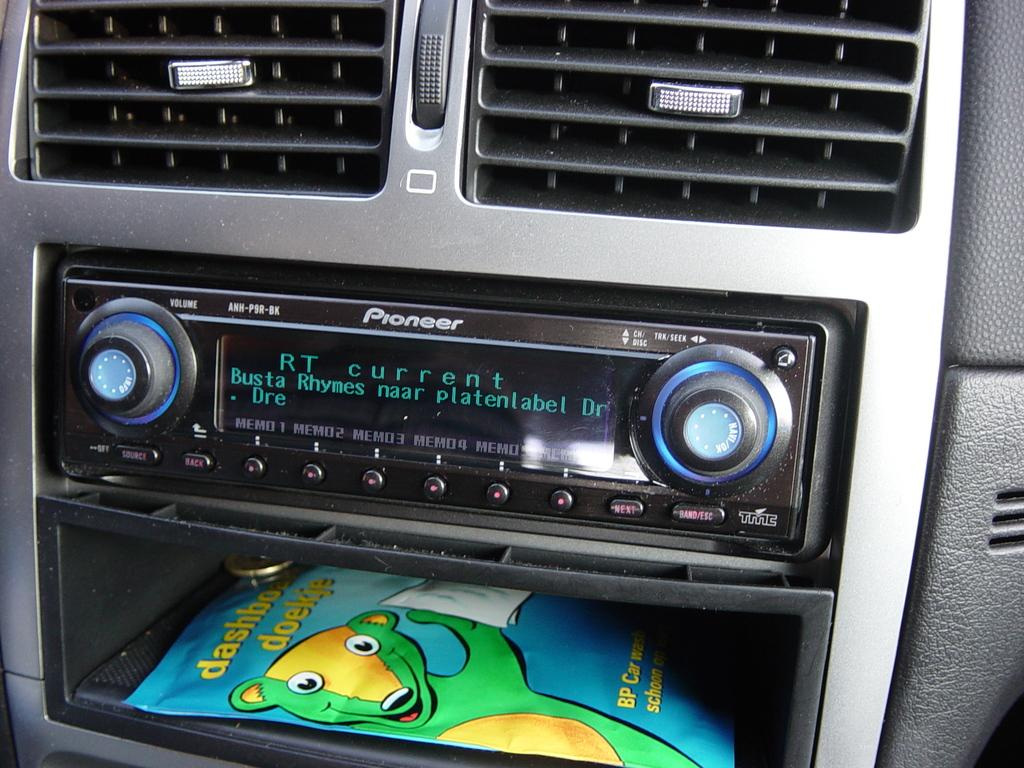What type of device is present in the car for playing music? There is a music player in the car. What feature is available in the car for maintaining a comfortable temperature? There is an air conditioning (AC) unit in the car. What is the design on the packet visible in the car? There is a packet with a cartoon of a bear on it. What type of object can be seen behind the packet? There is a coin visible behind the packet. Can you tell me where the monkey is sitting in the car? There is no monkey present in the car; the image only shows a music player, an AC unit, a packet with a bear cartoon, and a coin. What type of jewelry is the father wearing in the image? There is no father or locket present in the image. 